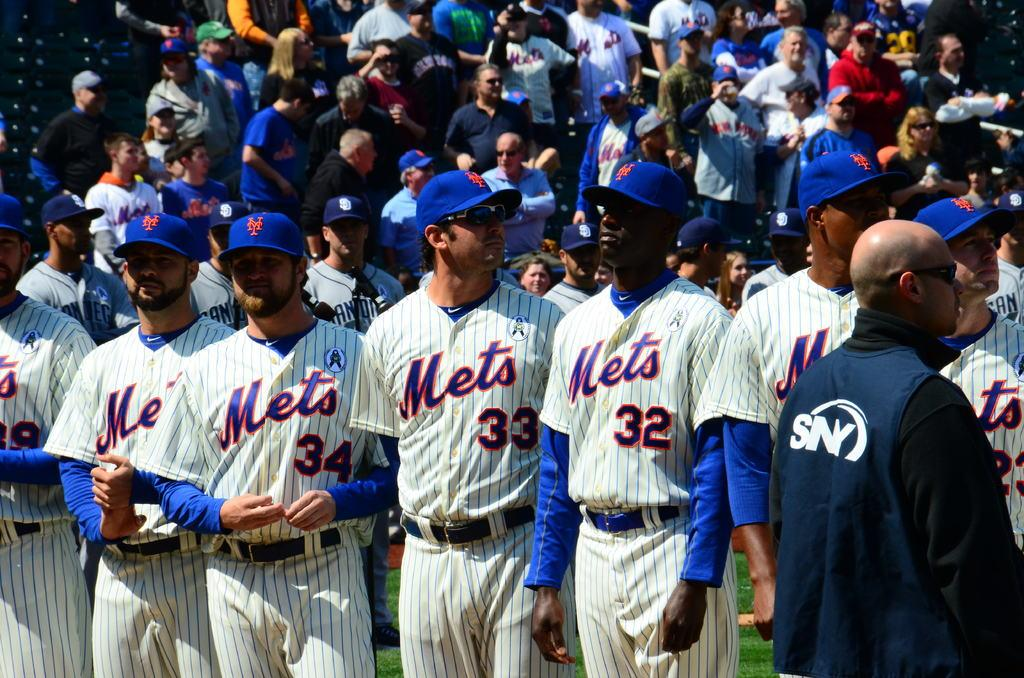Provide a one-sentence caption for the provided image. Six New York Mets in uniform in a row, including number's 32, 33, and 34. 